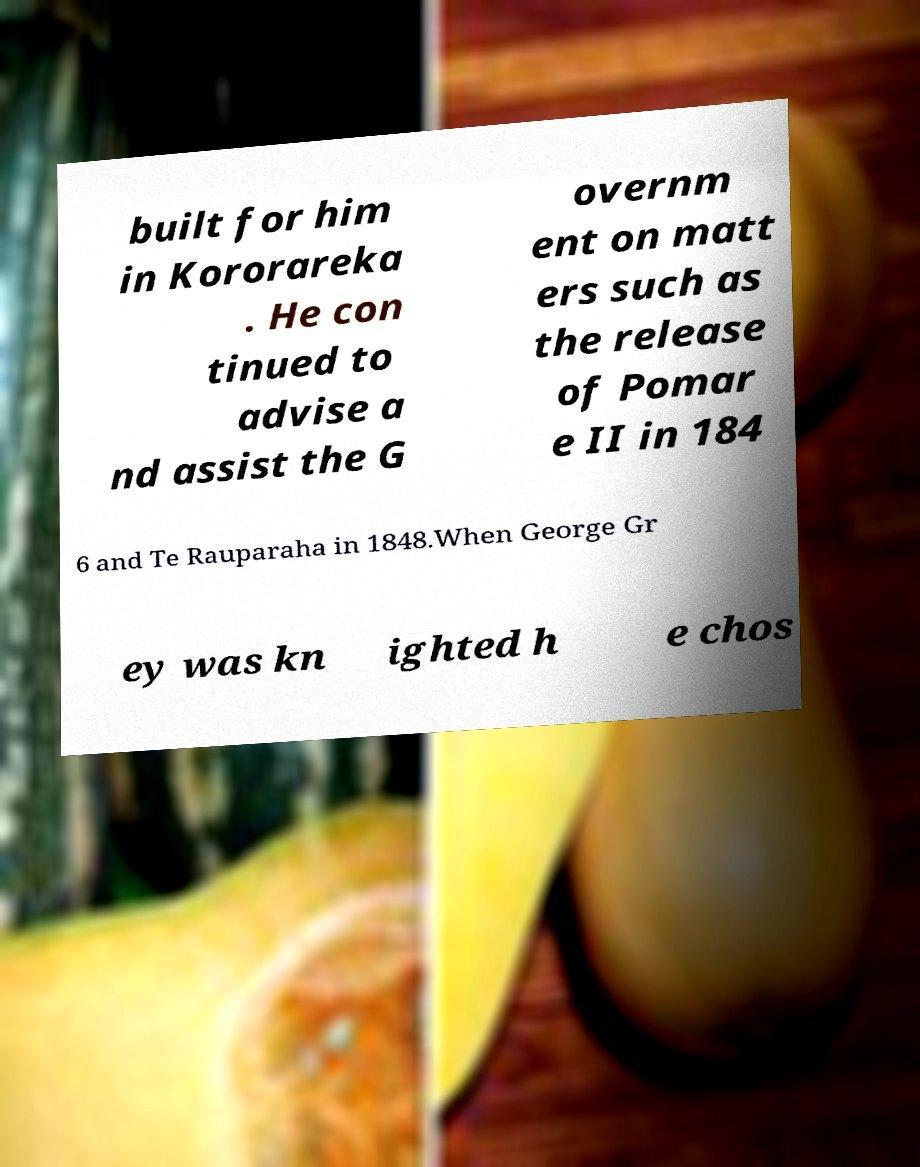Please identify and transcribe the text found in this image. built for him in Kororareka . He con tinued to advise a nd assist the G overnm ent on matt ers such as the release of Pomar e II in 184 6 and Te Rauparaha in 1848.When George Gr ey was kn ighted h e chos 